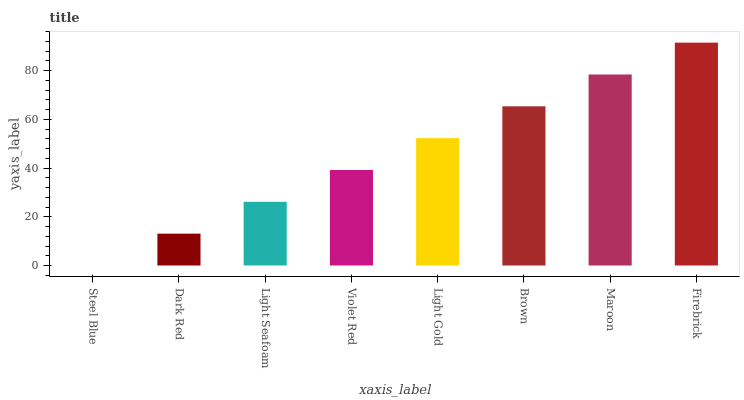Is Steel Blue the minimum?
Answer yes or no. Yes. Is Firebrick the maximum?
Answer yes or no. Yes. Is Dark Red the minimum?
Answer yes or no. No. Is Dark Red the maximum?
Answer yes or no. No. Is Dark Red greater than Steel Blue?
Answer yes or no. Yes. Is Steel Blue less than Dark Red?
Answer yes or no. Yes. Is Steel Blue greater than Dark Red?
Answer yes or no. No. Is Dark Red less than Steel Blue?
Answer yes or no. No. Is Light Gold the high median?
Answer yes or no. Yes. Is Violet Red the low median?
Answer yes or no. Yes. Is Maroon the high median?
Answer yes or no. No. Is Dark Red the low median?
Answer yes or no. No. 